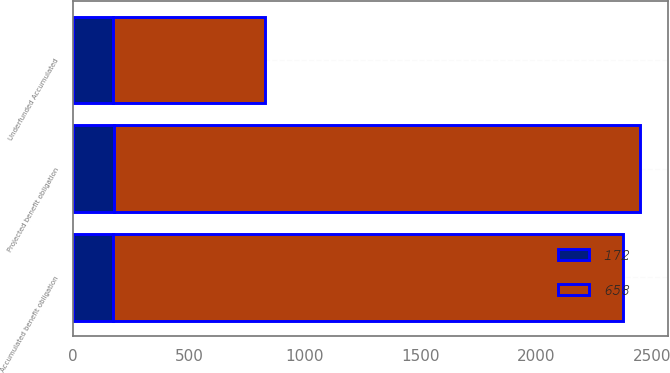<chart> <loc_0><loc_0><loc_500><loc_500><stacked_bar_chart><ecel><fcel>Underfunded Accumulated<fcel>Projected benefit obligation<fcel>Accumulated benefit obligation<nl><fcel>658<fcel>658<fcel>2272<fcel>2201<nl><fcel>172<fcel>172<fcel>175<fcel>172<nl></chart> 